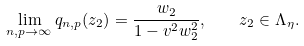<formula> <loc_0><loc_0><loc_500><loc_500>\lim _ { n , p \rightarrow \infty } q _ { n , p } ( z _ { 2 } ) = \frac { w _ { 2 } } { 1 - v ^ { 2 } w ^ { 2 } _ { 2 } } , \quad z _ { 2 } \in \Lambda _ { \eta } .</formula> 